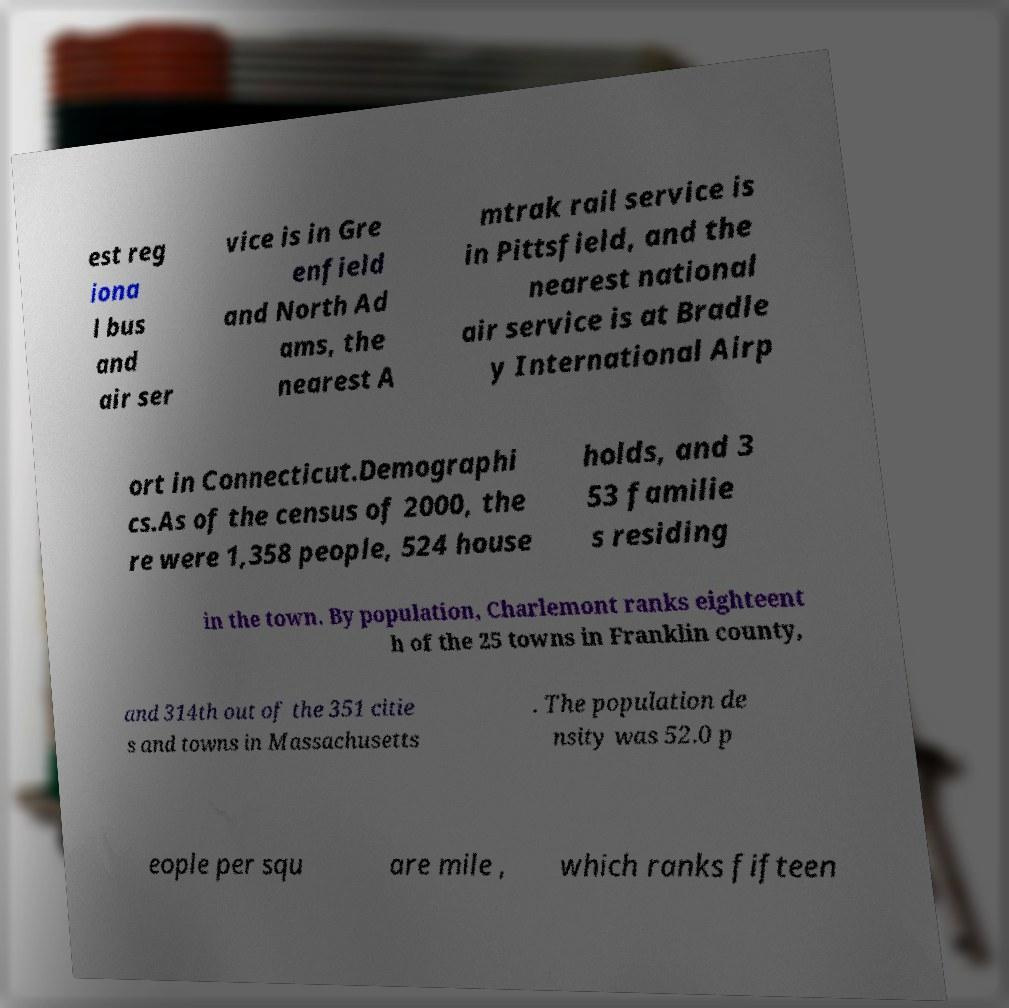What messages or text are displayed in this image? I need them in a readable, typed format. est reg iona l bus and air ser vice is in Gre enfield and North Ad ams, the nearest A mtrak rail service is in Pittsfield, and the nearest national air service is at Bradle y International Airp ort in Connecticut.Demographi cs.As of the census of 2000, the re were 1,358 people, 524 house holds, and 3 53 familie s residing in the town. By population, Charlemont ranks eighteent h of the 25 towns in Franklin county, and 314th out of the 351 citie s and towns in Massachusetts . The population de nsity was 52.0 p eople per squ are mile , which ranks fifteen 